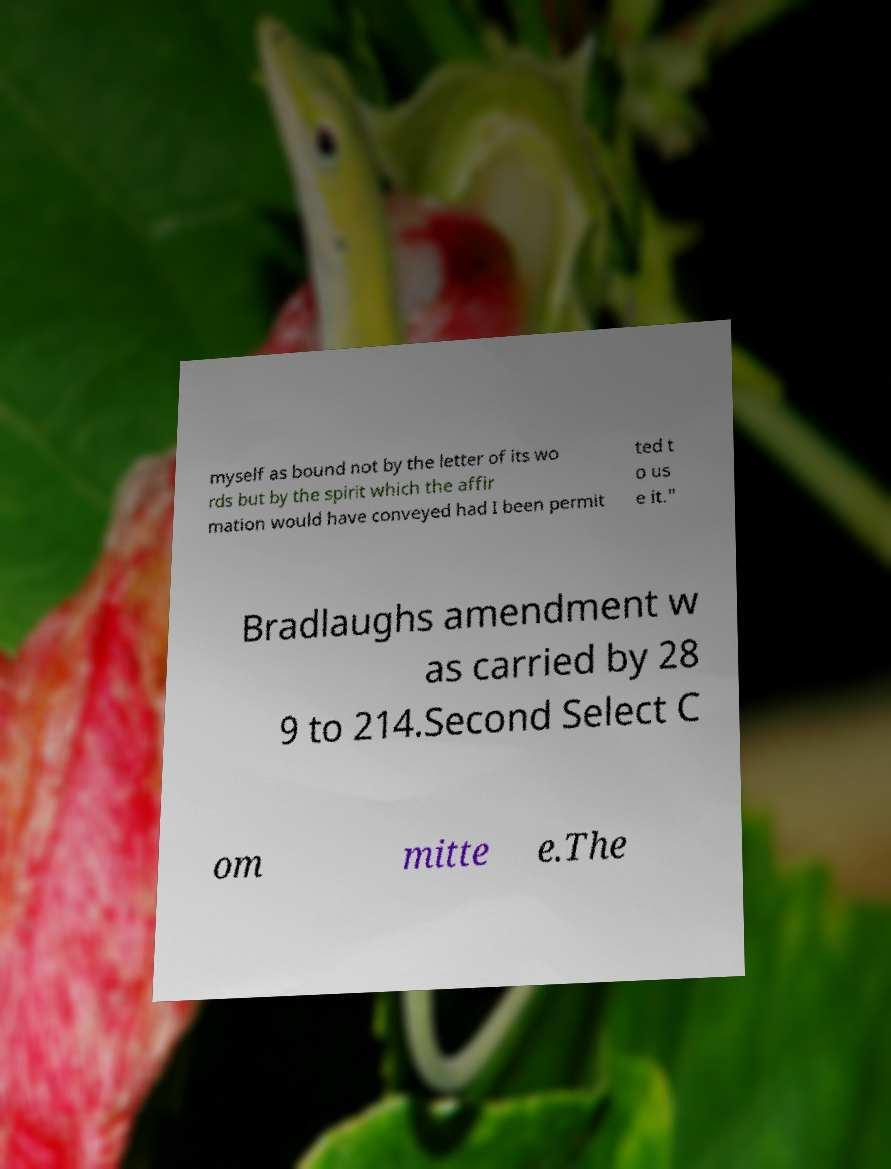There's text embedded in this image that I need extracted. Can you transcribe it verbatim? myself as bound not by the letter of its wo rds but by the spirit which the affir mation would have conveyed had I been permit ted t o us e it." Bradlaughs amendment w as carried by 28 9 to 214.Second Select C om mitte e.The 